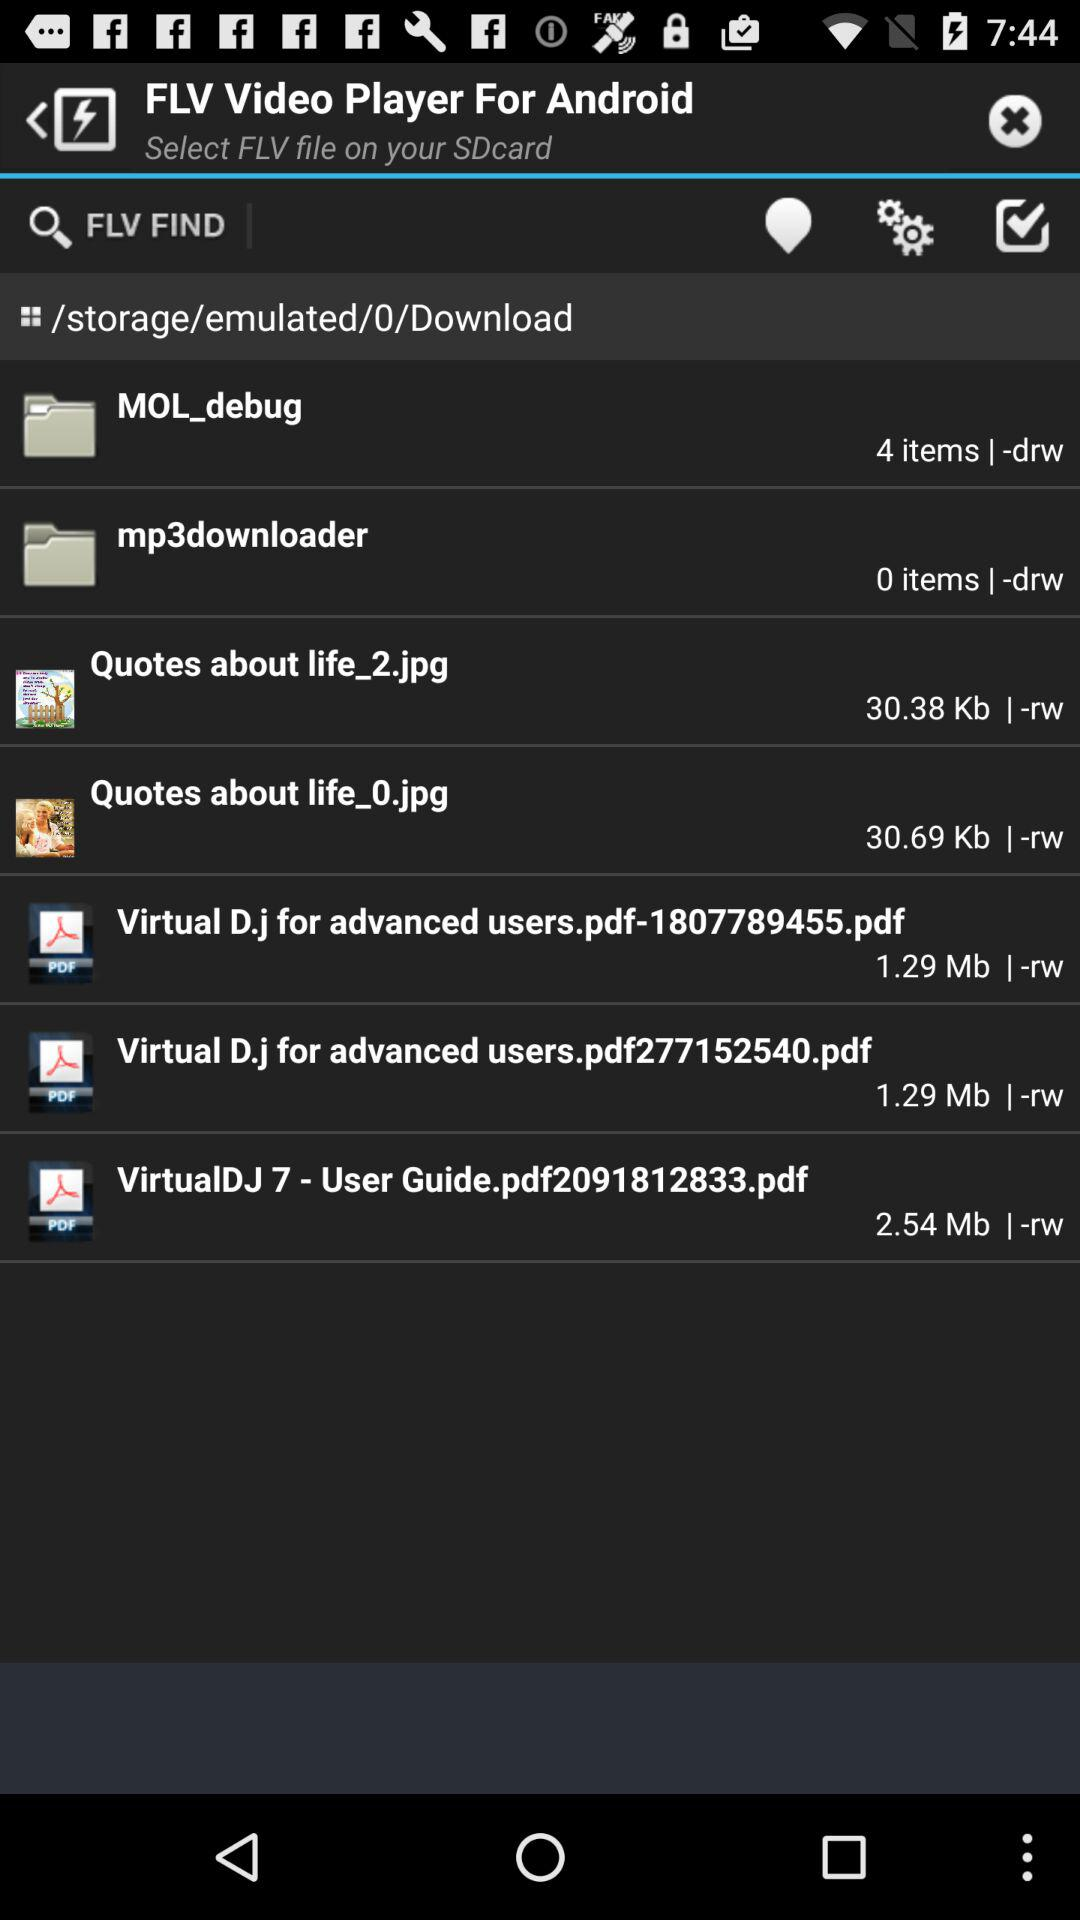How many items are there in the "mp3downloader"? There are 0 items in the "mp3downloader". 